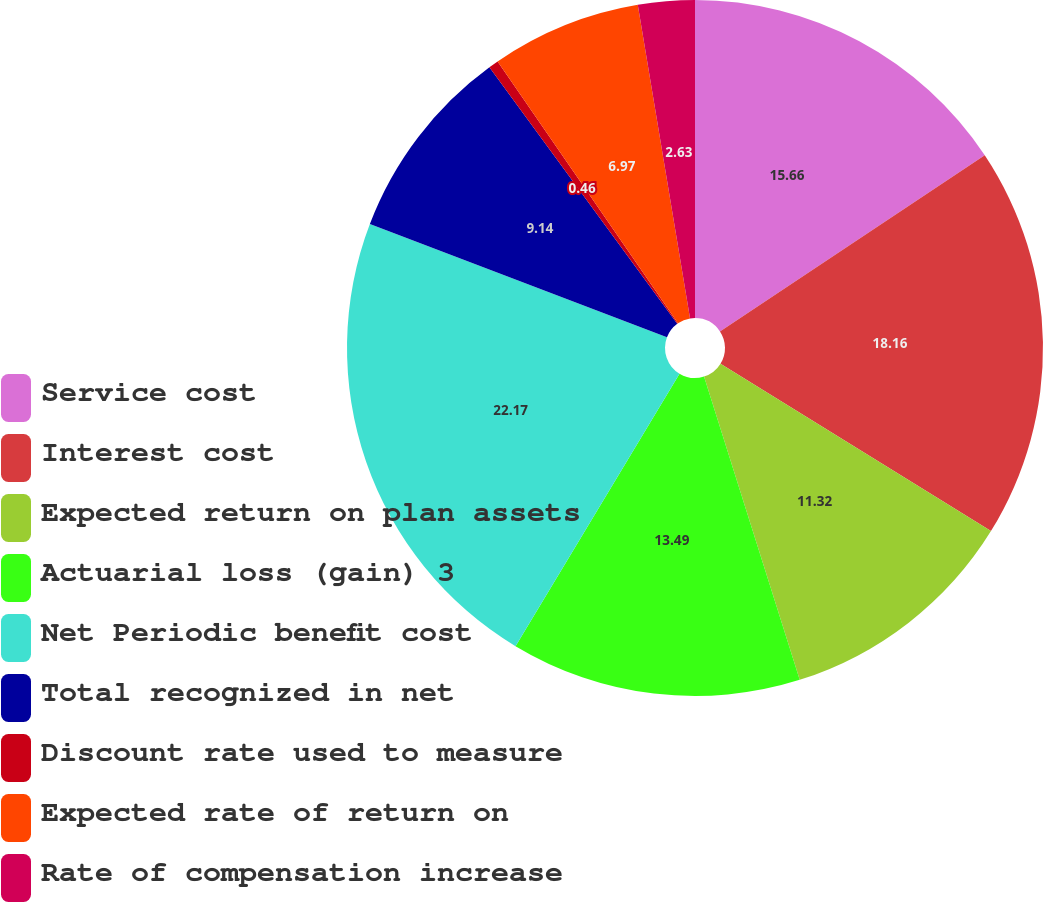Convert chart to OTSL. <chart><loc_0><loc_0><loc_500><loc_500><pie_chart><fcel>Service cost<fcel>Interest cost<fcel>Expected return on plan assets<fcel>Actuarial loss (gain) 3<fcel>Net Periodic benefit cost<fcel>Total recognized in net<fcel>Discount rate used to measure<fcel>Expected rate of return on<fcel>Rate of compensation increase<nl><fcel>15.66%<fcel>18.16%<fcel>11.32%<fcel>13.49%<fcel>22.18%<fcel>9.14%<fcel>0.46%<fcel>6.97%<fcel>2.63%<nl></chart> 